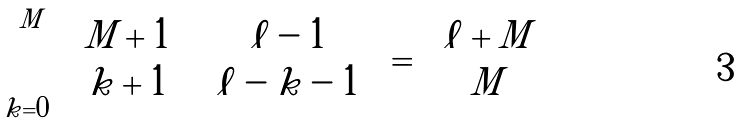Convert formula to latex. <formula><loc_0><loc_0><loc_500><loc_500>\sum _ { k = 0 } ^ { M } \binom { M + 1 } { k + 1 } \binom { \ell - 1 } { \ell - k - 1 } = \binom { \ell + M } { M }</formula> 